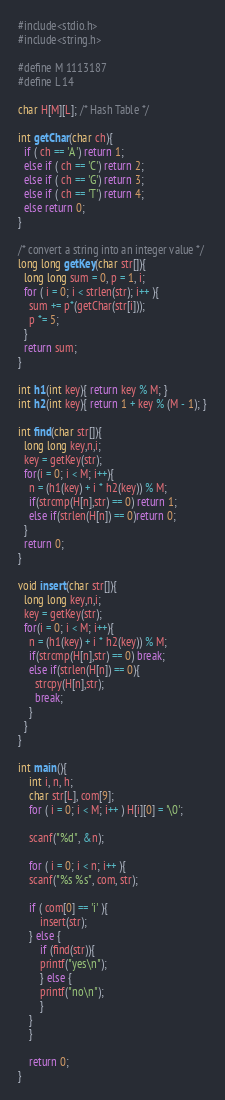<code> <loc_0><loc_0><loc_500><loc_500><_C_>#include<stdio.h>
#include<string.h>

#define M 1113187
#define L 14

char H[M][L]; /* Hash Table */

int getChar(char ch){
  if ( ch == 'A') return 1;
  else if ( ch == 'C') return 2;
  else if ( ch == 'G') return 3;
  else if ( ch == 'T') return 4;
  else return 0;
}

/* convert a string into an integer value */
long long getKey(char str[]){
  long long sum = 0, p = 1, i;
  for ( i = 0; i < strlen(str); i++ ){
    sum += p*(getChar(str[i]));
    p *= 5;
  }
  return sum;
}

int h1(int key){ return key % M; }
int h2(int key){ return 1 + key % (M - 1); }

int find(char str[]){
  long long key,n,i; 
  key = getKey(str);
  for(i = 0; i < M; i++){
    n = (h1(key) + i * h2(key)) % M;
    if(strcmp(H[n],str) == 0) return 1;
    else if(strlen(H[n]) == 0)return 0;
  }
  return 0;
}

void insert(char str[]){
  long long key,n,i; 
  key = getKey(str);
  for(i = 0; i < M; i++){
    n = (h1(key) + i * h2(key)) % M;
    if(strcmp(H[n],str) == 0) break;
    else if(strlen(H[n]) == 0){
      strcpy(H[n],str);
      break;
    }
  }
}

int main(){
    int i, n, h;
    char str[L], com[9];
    for ( i = 0; i < M; i++ ) H[i][0] = '\0';
    
    scanf("%d", &n);
    
    for ( i = 0; i < n; i++ ){
	scanf("%s %s", com, str);
	
	if ( com[0] == 'i' ){
	    insert(str);
	} else {
	    if (find(str)){
		printf("yes\n");
	    } else {
		printf("no\n");
	    }
	}
    }

    return 0;
}

</code> 